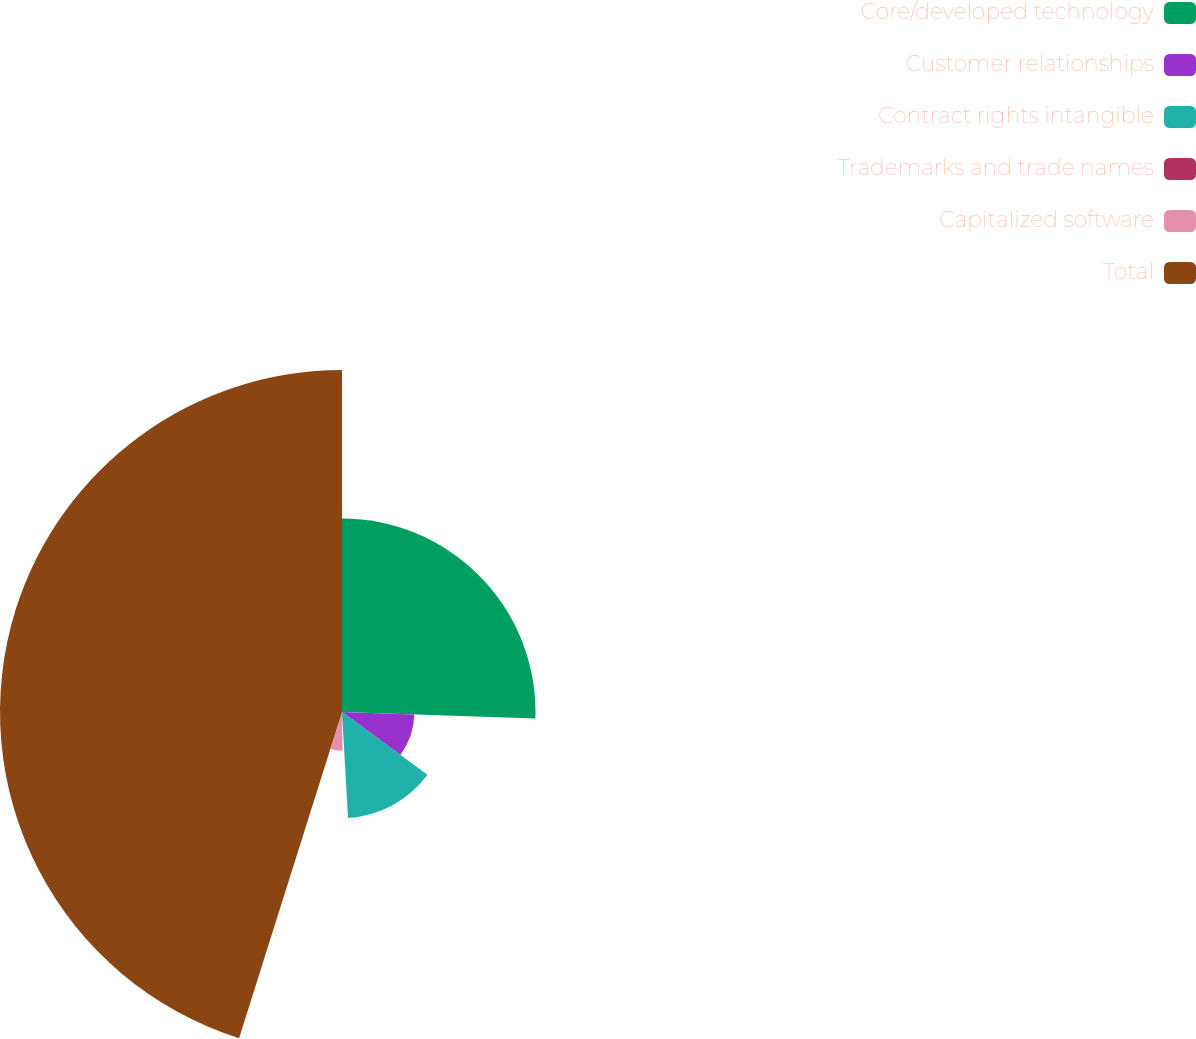Convert chart. <chart><loc_0><loc_0><loc_500><loc_500><pie_chart><fcel>Core/developed technology<fcel>Customer relationships<fcel>Contract rights intangible<fcel>Trademarks and trade names<fcel>Capitalized software<fcel>Total<nl><fcel>25.53%<fcel>9.56%<fcel>14.0%<fcel>0.66%<fcel>5.11%<fcel>45.13%<nl></chart> 